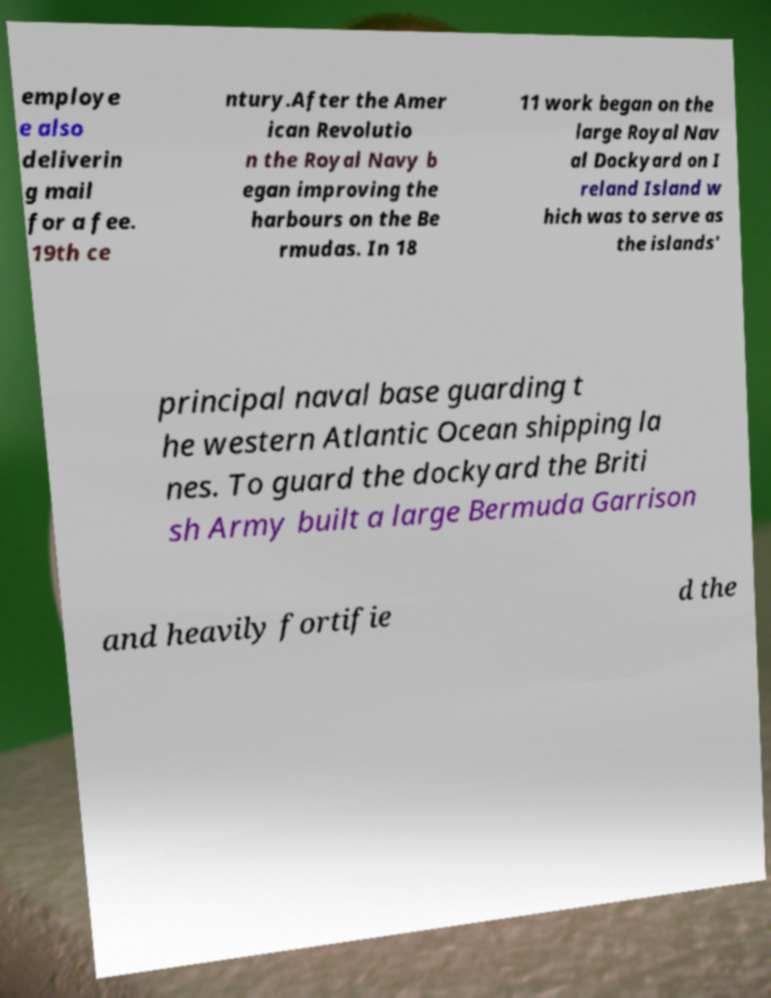What messages or text are displayed in this image? I need them in a readable, typed format. employe e also deliverin g mail for a fee. 19th ce ntury.After the Amer ican Revolutio n the Royal Navy b egan improving the harbours on the Be rmudas. In 18 11 work began on the large Royal Nav al Dockyard on I reland Island w hich was to serve as the islands' principal naval base guarding t he western Atlantic Ocean shipping la nes. To guard the dockyard the Briti sh Army built a large Bermuda Garrison and heavily fortifie d the 